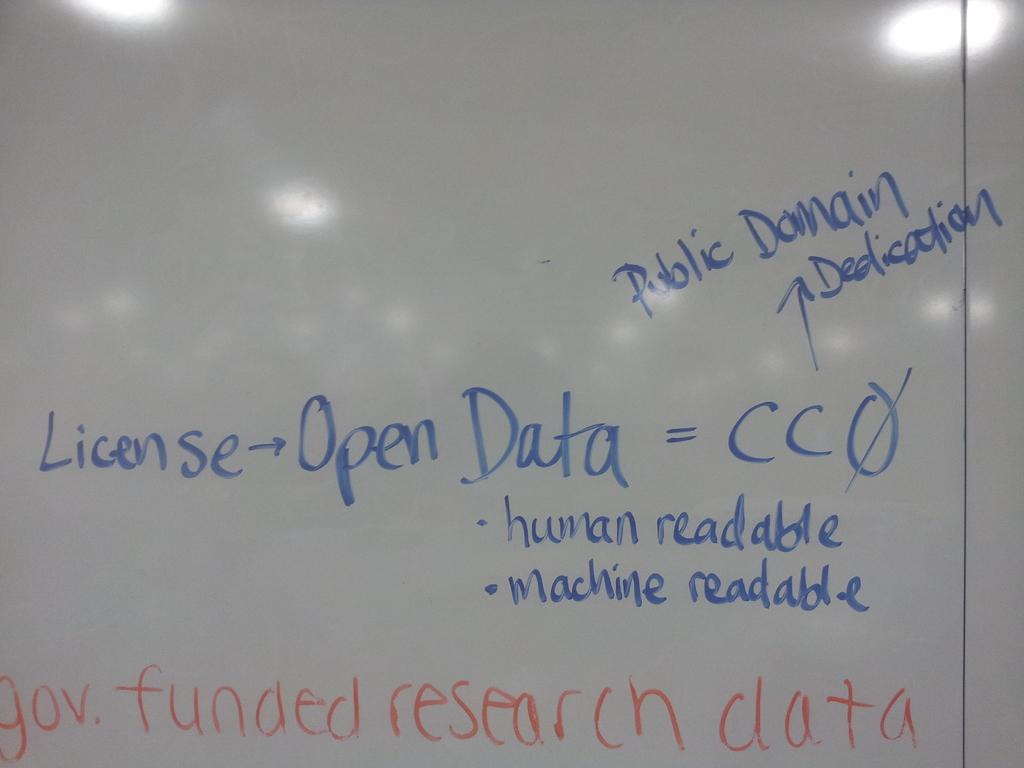<image>
Relay a brief, clear account of the picture shown. A white board with gov funded research data written in orange. 